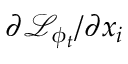Convert formula to latex. <formula><loc_0><loc_0><loc_500><loc_500>\partial \mathcal { L } _ { \phi _ { t } } / \partial x _ { i }</formula> 